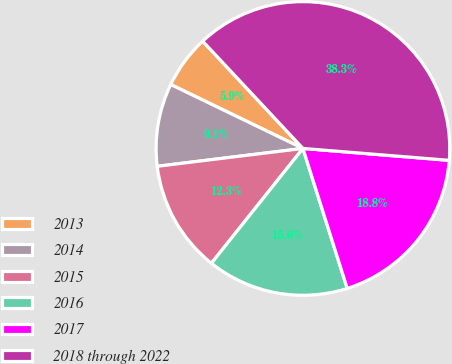Convert chart to OTSL. <chart><loc_0><loc_0><loc_500><loc_500><pie_chart><fcel>2013<fcel>2014<fcel>2015<fcel>2016<fcel>2017<fcel>2018 through 2022<nl><fcel>5.87%<fcel>9.11%<fcel>12.35%<fcel>15.59%<fcel>18.83%<fcel>38.26%<nl></chart> 